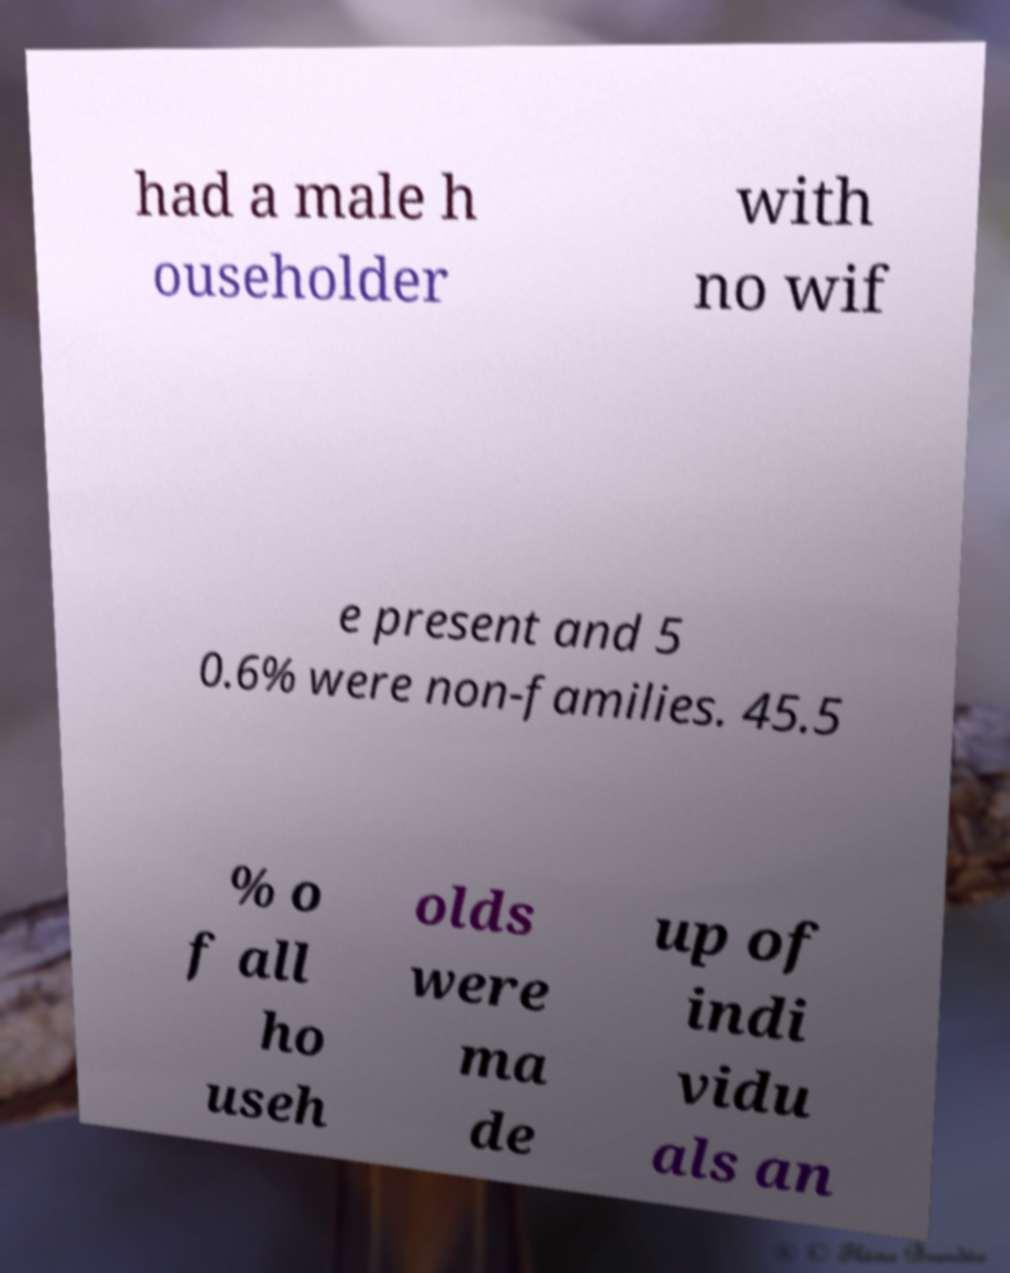Can you accurately transcribe the text from the provided image for me? had a male h ouseholder with no wif e present and 5 0.6% were non-families. 45.5 % o f all ho useh olds were ma de up of indi vidu als an 